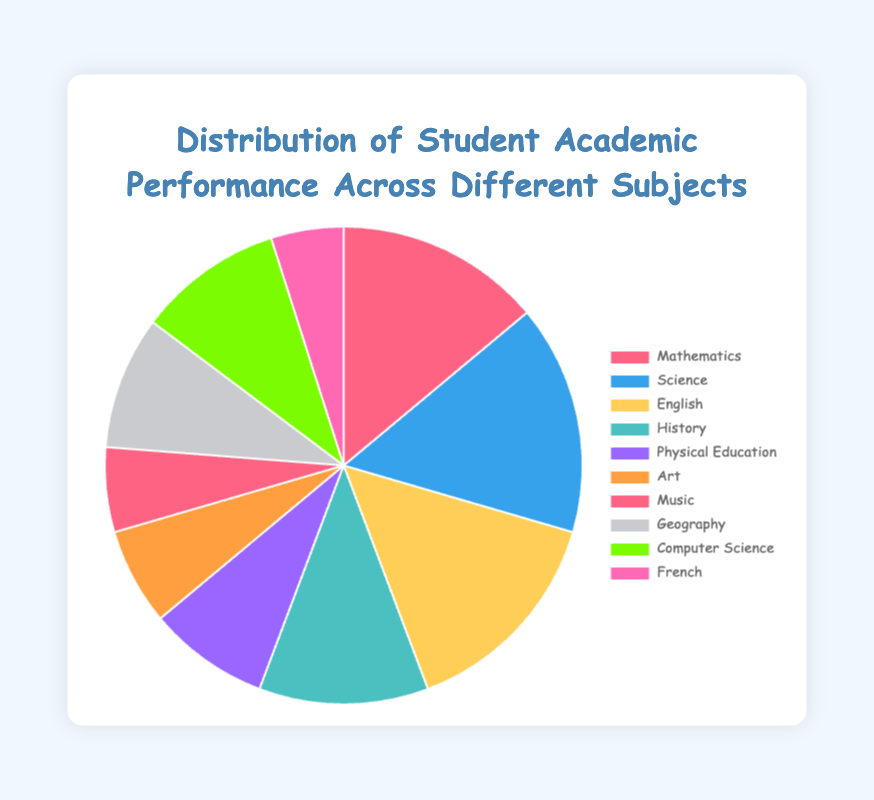Which subject has the highest student count among all? By observing the pie chart, the slice representing Science is the largest, indicating that it has the highest number of students compared to other subjects.
Answer: Science Which subject has the lowest student count? The smallest slice on the pie chart corresponds to French, suggesting it has the fewest students.
Answer: French How many more students are in English than in Geography? The slice for English shows 90 students, and the slice for Geography shows 55 students. The difference is 90 - 55.
Answer: 35 What proportion of students are in Science compared to the total number of students? Sum all the student counts: 85 + 95 + 90 + 70 + 50 + 40 + 35 + 55 + 60 + 30 = 610. The proportion for Science is 95 / 610.
Answer: 15.57% Which subject has a student count closest to that of Computer Science? Computer Science has 60 students. Looking at slices with similar sizes, Geography has 55 students, closest to Computer Science.
Answer: Geography What is the total number of students in Music, Art, and Physical Education combined? Add the student counts for Music (35), Art (40), and Physical Education (50): 35 + 40 + 50.
Answer: 125 Are there more students in Mathematics combined with English than in Science and History together? Add the student counts for Math (85) and English (90): 85 + 90 = 175. Add the counts for Science (95) and History (70): 95 + 70 = 165. Compare 175 with 165.
Answer: Yes What is the difference in student count between the two subjects with the largest student numbers? The two subjects with the largest student counts are Science (95) and English (90). The difference is 95 - 90.
Answer: 5 Which color in the pie chart represents Mathematics? By observing the pie chart legend, Mathematics is represented with a red color.
Answer: Red 